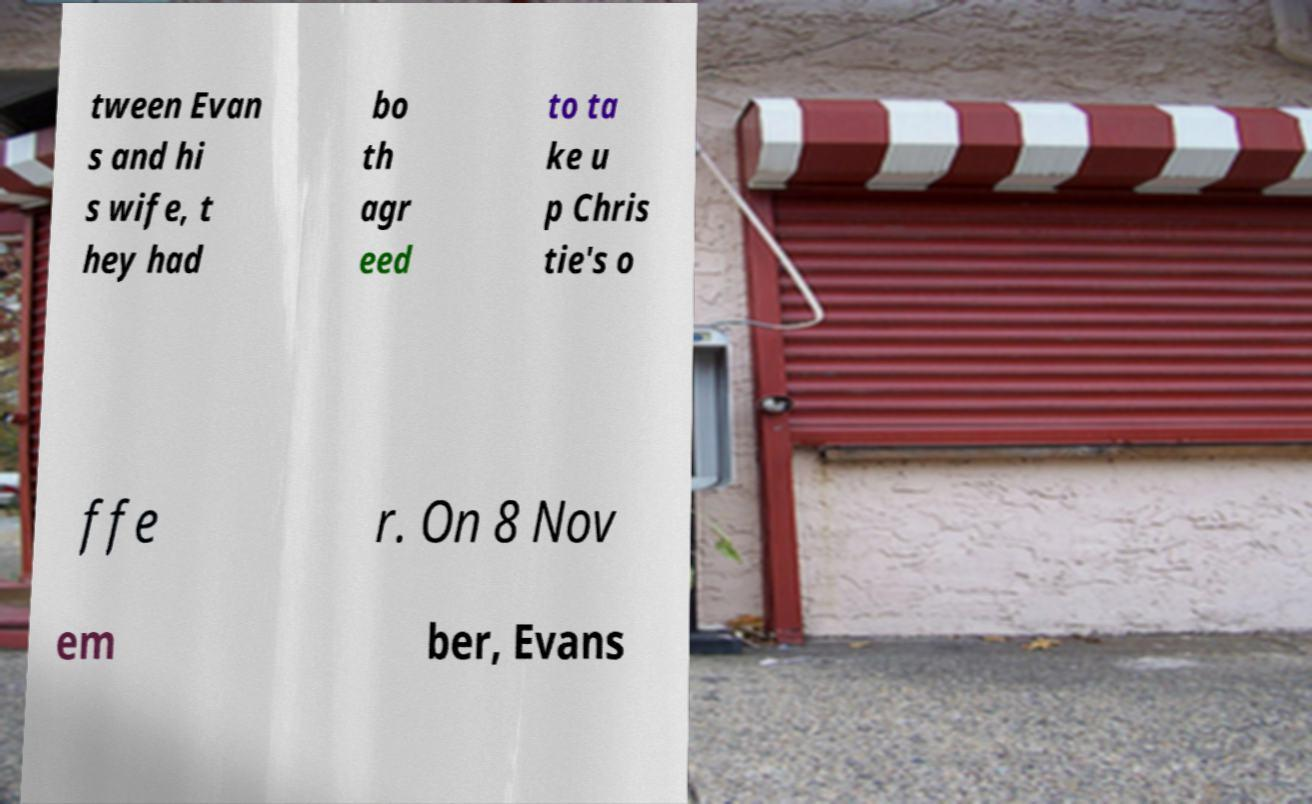Could you assist in decoding the text presented in this image and type it out clearly? tween Evan s and hi s wife, t hey had bo th agr eed to ta ke u p Chris tie's o ffe r. On 8 Nov em ber, Evans 